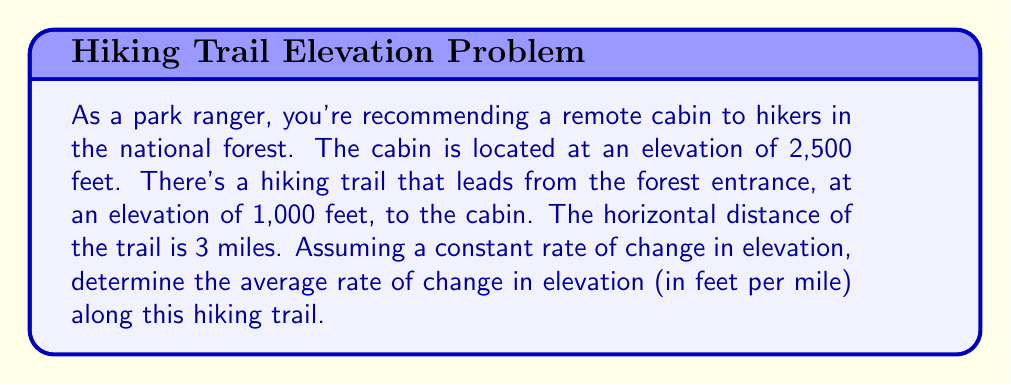Provide a solution to this math problem. To solve this problem, we'll use the concept of slope, which represents the rate of change. The slope formula is:

$$\text{slope} = \frac{\text{change in y}}{\text{change in x}} = \frac{\text{rise}}{\text{run}}$$

In this case:
- Change in y (rise) = Change in elevation
- Change in x (run) = Horizontal distance

Let's identify our values:
1. Initial elevation (forest entrance): 1,000 feet
2. Final elevation (cabin): 2,500 feet
3. Horizontal distance: 3 miles

Now, let's calculate:

1. Change in elevation:
   $$\Delta y = \text{Final elevation} - \text{Initial elevation}$$
   $$\Delta y = 2,500 \text{ feet} - 1,000 \text{ feet} = 1,500 \text{ feet}$$

2. Horizontal distance:
   $$\Delta x = 3 \text{ miles}$$

3. Apply the slope formula:
   $$\text{slope} = \frac{\Delta y}{\Delta x} = \frac{1,500 \text{ feet}}{3 \text{ miles}} = 500 \text{ feet/mile}$$

Therefore, the average rate of change in elevation along the hiking trail is 500 feet per mile.
Answer: 500 feet per mile 